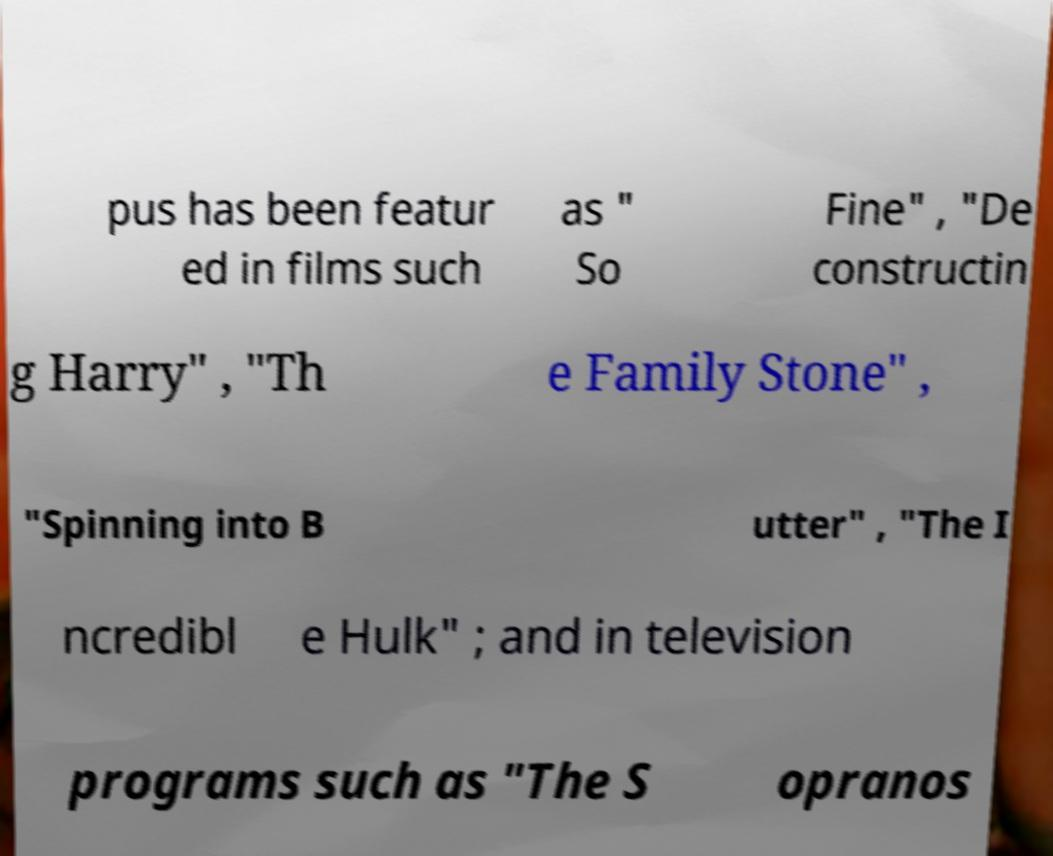Can you read and provide the text displayed in the image?This photo seems to have some interesting text. Can you extract and type it out for me? pus has been featur ed in films such as " So Fine" , "De constructin g Harry" , "Th e Family Stone" , "Spinning into B utter" , "The I ncredibl e Hulk" ; and in television programs such as "The S opranos 